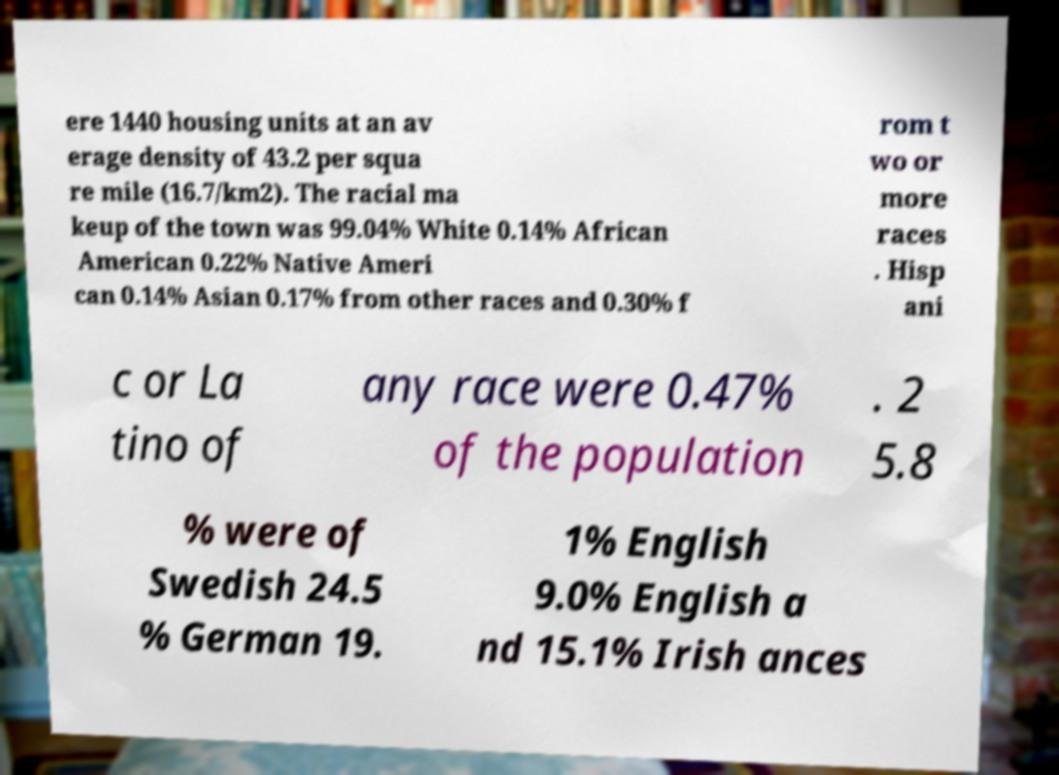Please read and relay the text visible in this image. What does it say? ere 1440 housing units at an av erage density of 43.2 per squa re mile (16.7/km2). The racial ma keup of the town was 99.04% White 0.14% African American 0.22% Native Ameri can 0.14% Asian 0.17% from other races and 0.30% f rom t wo or more races . Hisp ani c or La tino of any race were 0.47% of the population . 2 5.8 % were of Swedish 24.5 % German 19. 1% English 9.0% English a nd 15.1% Irish ances 